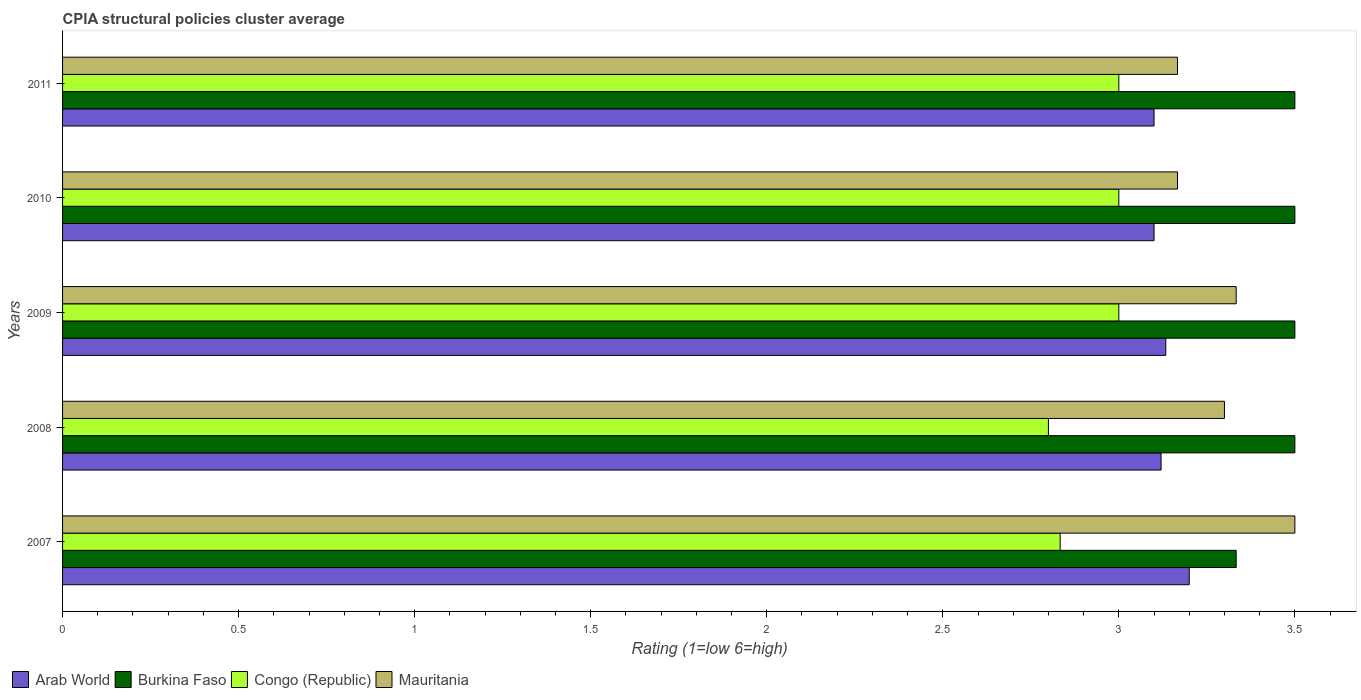How many groups of bars are there?
Your response must be concise. 5. Are the number of bars on each tick of the Y-axis equal?
Provide a succinct answer. Yes. How many bars are there on the 4th tick from the top?
Provide a succinct answer. 4. What is the label of the 5th group of bars from the top?
Ensure brevity in your answer.  2007. What is the CPIA rating in Congo (Republic) in 2009?
Your response must be concise. 3. Across all years, what is the minimum CPIA rating in Arab World?
Ensure brevity in your answer.  3.1. What is the total CPIA rating in Mauritania in the graph?
Give a very brief answer. 16.47. What is the difference between the CPIA rating in Mauritania in 2009 and the CPIA rating in Congo (Republic) in 2008?
Give a very brief answer. 0.53. What is the average CPIA rating in Congo (Republic) per year?
Provide a succinct answer. 2.93. In the year 2010, what is the difference between the CPIA rating in Congo (Republic) and CPIA rating in Arab World?
Provide a short and direct response. -0.1. In how many years, is the CPIA rating in Arab World greater than 2.4 ?
Keep it short and to the point. 5. What is the ratio of the CPIA rating in Burkina Faso in 2008 to that in 2009?
Offer a terse response. 1. What is the difference between the highest and the second highest CPIA rating in Burkina Faso?
Your answer should be very brief. 0. What is the difference between the highest and the lowest CPIA rating in Burkina Faso?
Provide a succinct answer. 0.17. Is it the case that in every year, the sum of the CPIA rating in Congo (Republic) and CPIA rating in Arab World is greater than the sum of CPIA rating in Mauritania and CPIA rating in Burkina Faso?
Your response must be concise. No. What does the 2nd bar from the top in 2008 represents?
Provide a succinct answer. Congo (Republic). What does the 4th bar from the bottom in 2010 represents?
Your answer should be very brief. Mauritania. How many bars are there?
Your response must be concise. 20. Are all the bars in the graph horizontal?
Offer a very short reply. Yes. What is the difference between two consecutive major ticks on the X-axis?
Your response must be concise. 0.5. Does the graph contain any zero values?
Your answer should be very brief. No. How are the legend labels stacked?
Your answer should be very brief. Horizontal. What is the title of the graph?
Make the answer very short. CPIA structural policies cluster average. Does "Sint Maarten (Dutch part)" appear as one of the legend labels in the graph?
Give a very brief answer. No. What is the label or title of the X-axis?
Offer a very short reply. Rating (1=low 6=high). What is the label or title of the Y-axis?
Provide a succinct answer. Years. What is the Rating (1=low 6=high) of Arab World in 2007?
Ensure brevity in your answer.  3.2. What is the Rating (1=low 6=high) of Burkina Faso in 2007?
Your answer should be very brief. 3.33. What is the Rating (1=low 6=high) of Congo (Republic) in 2007?
Keep it short and to the point. 2.83. What is the Rating (1=low 6=high) of Mauritania in 2007?
Provide a short and direct response. 3.5. What is the Rating (1=low 6=high) in Arab World in 2008?
Your response must be concise. 3.12. What is the Rating (1=low 6=high) of Mauritania in 2008?
Provide a succinct answer. 3.3. What is the Rating (1=low 6=high) in Arab World in 2009?
Give a very brief answer. 3.13. What is the Rating (1=low 6=high) of Burkina Faso in 2009?
Keep it short and to the point. 3.5. What is the Rating (1=low 6=high) of Congo (Republic) in 2009?
Offer a very short reply. 3. What is the Rating (1=low 6=high) of Mauritania in 2009?
Provide a succinct answer. 3.33. What is the Rating (1=low 6=high) of Arab World in 2010?
Provide a short and direct response. 3.1. What is the Rating (1=low 6=high) in Burkina Faso in 2010?
Provide a succinct answer. 3.5. What is the Rating (1=low 6=high) in Congo (Republic) in 2010?
Offer a very short reply. 3. What is the Rating (1=low 6=high) in Mauritania in 2010?
Offer a terse response. 3.17. What is the Rating (1=low 6=high) of Arab World in 2011?
Your answer should be compact. 3.1. What is the Rating (1=low 6=high) in Burkina Faso in 2011?
Offer a very short reply. 3.5. What is the Rating (1=low 6=high) of Mauritania in 2011?
Keep it short and to the point. 3.17. Across all years, what is the maximum Rating (1=low 6=high) of Burkina Faso?
Your answer should be compact. 3.5. Across all years, what is the maximum Rating (1=low 6=high) in Congo (Republic)?
Provide a succinct answer. 3. Across all years, what is the maximum Rating (1=low 6=high) in Mauritania?
Ensure brevity in your answer.  3.5. Across all years, what is the minimum Rating (1=low 6=high) in Arab World?
Your answer should be very brief. 3.1. Across all years, what is the minimum Rating (1=low 6=high) in Burkina Faso?
Give a very brief answer. 3.33. Across all years, what is the minimum Rating (1=low 6=high) in Mauritania?
Ensure brevity in your answer.  3.17. What is the total Rating (1=low 6=high) in Arab World in the graph?
Make the answer very short. 15.65. What is the total Rating (1=low 6=high) of Burkina Faso in the graph?
Give a very brief answer. 17.33. What is the total Rating (1=low 6=high) of Congo (Republic) in the graph?
Keep it short and to the point. 14.63. What is the total Rating (1=low 6=high) in Mauritania in the graph?
Offer a very short reply. 16.47. What is the difference between the Rating (1=low 6=high) of Congo (Republic) in 2007 and that in 2008?
Ensure brevity in your answer.  0.03. What is the difference between the Rating (1=low 6=high) in Mauritania in 2007 and that in 2008?
Provide a short and direct response. 0.2. What is the difference between the Rating (1=low 6=high) of Arab World in 2007 and that in 2009?
Your response must be concise. 0.07. What is the difference between the Rating (1=low 6=high) of Congo (Republic) in 2007 and that in 2009?
Your answer should be very brief. -0.17. What is the difference between the Rating (1=low 6=high) of Mauritania in 2007 and that in 2009?
Keep it short and to the point. 0.17. What is the difference between the Rating (1=low 6=high) of Arab World in 2007 and that in 2010?
Offer a terse response. 0.1. What is the difference between the Rating (1=low 6=high) in Congo (Republic) in 2007 and that in 2010?
Ensure brevity in your answer.  -0.17. What is the difference between the Rating (1=low 6=high) of Mauritania in 2007 and that in 2010?
Your answer should be compact. 0.33. What is the difference between the Rating (1=low 6=high) in Burkina Faso in 2007 and that in 2011?
Your response must be concise. -0.17. What is the difference between the Rating (1=low 6=high) of Arab World in 2008 and that in 2009?
Your answer should be very brief. -0.01. What is the difference between the Rating (1=low 6=high) of Burkina Faso in 2008 and that in 2009?
Your response must be concise. 0. What is the difference between the Rating (1=low 6=high) in Mauritania in 2008 and that in 2009?
Provide a short and direct response. -0.03. What is the difference between the Rating (1=low 6=high) in Burkina Faso in 2008 and that in 2010?
Provide a short and direct response. 0. What is the difference between the Rating (1=low 6=high) in Mauritania in 2008 and that in 2010?
Keep it short and to the point. 0.13. What is the difference between the Rating (1=low 6=high) in Congo (Republic) in 2008 and that in 2011?
Offer a terse response. -0.2. What is the difference between the Rating (1=low 6=high) in Mauritania in 2008 and that in 2011?
Ensure brevity in your answer.  0.13. What is the difference between the Rating (1=low 6=high) in Arab World in 2009 and that in 2010?
Keep it short and to the point. 0.03. What is the difference between the Rating (1=low 6=high) of Mauritania in 2009 and that in 2010?
Offer a terse response. 0.17. What is the difference between the Rating (1=low 6=high) in Burkina Faso in 2009 and that in 2011?
Offer a very short reply. 0. What is the difference between the Rating (1=low 6=high) of Mauritania in 2009 and that in 2011?
Give a very brief answer. 0.17. What is the difference between the Rating (1=low 6=high) in Arab World in 2007 and the Rating (1=low 6=high) in Burkina Faso in 2008?
Provide a succinct answer. -0.3. What is the difference between the Rating (1=low 6=high) in Arab World in 2007 and the Rating (1=low 6=high) in Congo (Republic) in 2008?
Provide a short and direct response. 0.4. What is the difference between the Rating (1=low 6=high) in Burkina Faso in 2007 and the Rating (1=low 6=high) in Congo (Republic) in 2008?
Provide a short and direct response. 0.53. What is the difference between the Rating (1=low 6=high) in Congo (Republic) in 2007 and the Rating (1=low 6=high) in Mauritania in 2008?
Provide a succinct answer. -0.47. What is the difference between the Rating (1=low 6=high) in Arab World in 2007 and the Rating (1=low 6=high) in Burkina Faso in 2009?
Your answer should be very brief. -0.3. What is the difference between the Rating (1=low 6=high) of Arab World in 2007 and the Rating (1=low 6=high) of Mauritania in 2009?
Your answer should be compact. -0.13. What is the difference between the Rating (1=low 6=high) of Arab World in 2007 and the Rating (1=low 6=high) of Congo (Republic) in 2010?
Offer a very short reply. 0.2. What is the difference between the Rating (1=low 6=high) in Arab World in 2007 and the Rating (1=low 6=high) in Mauritania in 2010?
Provide a succinct answer. 0.03. What is the difference between the Rating (1=low 6=high) in Burkina Faso in 2007 and the Rating (1=low 6=high) in Mauritania in 2010?
Make the answer very short. 0.17. What is the difference between the Rating (1=low 6=high) in Arab World in 2007 and the Rating (1=low 6=high) in Congo (Republic) in 2011?
Make the answer very short. 0.2. What is the difference between the Rating (1=low 6=high) of Burkina Faso in 2007 and the Rating (1=low 6=high) of Congo (Republic) in 2011?
Offer a terse response. 0.33. What is the difference between the Rating (1=low 6=high) in Congo (Republic) in 2007 and the Rating (1=low 6=high) in Mauritania in 2011?
Ensure brevity in your answer.  -0.33. What is the difference between the Rating (1=low 6=high) of Arab World in 2008 and the Rating (1=low 6=high) of Burkina Faso in 2009?
Make the answer very short. -0.38. What is the difference between the Rating (1=low 6=high) in Arab World in 2008 and the Rating (1=low 6=high) in Congo (Republic) in 2009?
Ensure brevity in your answer.  0.12. What is the difference between the Rating (1=low 6=high) in Arab World in 2008 and the Rating (1=low 6=high) in Mauritania in 2009?
Make the answer very short. -0.21. What is the difference between the Rating (1=low 6=high) of Congo (Republic) in 2008 and the Rating (1=low 6=high) of Mauritania in 2009?
Provide a succinct answer. -0.53. What is the difference between the Rating (1=low 6=high) of Arab World in 2008 and the Rating (1=low 6=high) of Burkina Faso in 2010?
Offer a terse response. -0.38. What is the difference between the Rating (1=low 6=high) of Arab World in 2008 and the Rating (1=low 6=high) of Congo (Republic) in 2010?
Provide a succinct answer. 0.12. What is the difference between the Rating (1=low 6=high) of Arab World in 2008 and the Rating (1=low 6=high) of Mauritania in 2010?
Provide a succinct answer. -0.05. What is the difference between the Rating (1=low 6=high) in Burkina Faso in 2008 and the Rating (1=low 6=high) in Mauritania in 2010?
Your answer should be very brief. 0.33. What is the difference between the Rating (1=low 6=high) of Congo (Republic) in 2008 and the Rating (1=low 6=high) of Mauritania in 2010?
Keep it short and to the point. -0.37. What is the difference between the Rating (1=low 6=high) in Arab World in 2008 and the Rating (1=low 6=high) in Burkina Faso in 2011?
Make the answer very short. -0.38. What is the difference between the Rating (1=low 6=high) of Arab World in 2008 and the Rating (1=low 6=high) of Congo (Republic) in 2011?
Your answer should be very brief. 0.12. What is the difference between the Rating (1=low 6=high) in Arab World in 2008 and the Rating (1=low 6=high) in Mauritania in 2011?
Make the answer very short. -0.05. What is the difference between the Rating (1=low 6=high) in Burkina Faso in 2008 and the Rating (1=low 6=high) in Congo (Republic) in 2011?
Offer a terse response. 0.5. What is the difference between the Rating (1=low 6=high) in Burkina Faso in 2008 and the Rating (1=low 6=high) in Mauritania in 2011?
Keep it short and to the point. 0.33. What is the difference between the Rating (1=low 6=high) of Congo (Republic) in 2008 and the Rating (1=low 6=high) of Mauritania in 2011?
Offer a very short reply. -0.37. What is the difference between the Rating (1=low 6=high) of Arab World in 2009 and the Rating (1=low 6=high) of Burkina Faso in 2010?
Provide a succinct answer. -0.37. What is the difference between the Rating (1=low 6=high) of Arab World in 2009 and the Rating (1=low 6=high) of Congo (Republic) in 2010?
Make the answer very short. 0.13. What is the difference between the Rating (1=low 6=high) in Arab World in 2009 and the Rating (1=low 6=high) in Mauritania in 2010?
Your answer should be compact. -0.03. What is the difference between the Rating (1=low 6=high) of Burkina Faso in 2009 and the Rating (1=low 6=high) of Mauritania in 2010?
Provide a short and direct response. 0.33. What is the difference between the Rating (1=low 6=high) in Congo (Republic) in 2009 and the Rating (1=low 6=high) in Mauritania in 2010?
Your answer should be compact. -0.17. What is the difference between the Rating (1=low 6=high) of Arab World in 2009 and the Rating (1=low 6=high) of Burkina Faso in 2011?
Your answer should be very brief. -0.37. What is the difference between the Rating (1=low 6=high) in Arab World in 2009 and the Rating (1=low 6=high) in Congo (Republic) in 2011?
Ensure brevity in your answer.  0.13. What is the difference between the Rating (1=low 6=high) of Arab World in 2009 and the Rating (1=low 6=high) of Mauritania in 2011?
Your answer should be very brief. -0.03. What is the difference between the Rating (1=low 6=high) in Burkina Faso in 2009 and the Rating (1=low 6=high) in Congo (Republic) in 2011?
Your response must be concise. 0.5. What is the difference between the Rating (1=low 6=high) of Burkina Faso in 2009 and the Rating (1=low 6=high) of Mauritania in 2011?
Offer a very short reply. 0.33. What is the difference between the Rating (1=low 6=high) of Arab World in 2010 and the Rating (1=low 6=high) of Burkina Faso in 2011?
Your answer should be compact. -0.4. What is the difference between the Rating (1=low 6=high) of Arab World in 2010 and the Rating (1=low 6=high) of Mauritania in 2011?
Give a very brief answer. -0.07. What is the difference between the Rating (1=low 6=high) of Congo (Republic) in 2010 and the Rating (1=low 6=high) of Mauritania in 2011?
Keep it short and to the point. -0.17. What is the average Rating (1=low 6=high) of Arab World per year?
Offer a terse response. 3.13. What is the average Rating (1=low 6=high) of Burkina Faso per year?
Your answer should be compact. 3.47. What is the average Rating (1=low 6=high) in Congo (Republic) per year?
Make the answer very short. 2.93. What is the average Rating (1=low 6=high) in Mauritania per year?
Make the answer very short. 3.29. In the year 2007, what is the difference between the Rating (1=low 6=high) in Arab World and Rating (1=low 6=high) in Burkina Faso?
Give a very brief answer. -0.13. In the year 2007, what is the difference between the Rating (1=low 6=high) in Arab World and Rating (1=low 6=high) in Congo (Republic)?
Your response must be concise. 0.37. In the year 2007, what is the difference between the Rating (1=low 6=high) in Arab World and Rating (1=low 6=high) in Mauritania?
Give a very brief answer. -0.3. In the year 2007, what is the difference between the Rating (1=low 6=high) in Burkina Faso and Rating (1=low 6=high) in Congo (Republic)?
Offer a terse response. 0.5. In the year 2008, what is the difference between the Rating (1=low 6=high) in Arab World and Rating (1=low 6=high) in Burkina Faso?
Your answer should be compact. -0.38. In the year 2008, what is the difference between the Rating (1=low 6=high) of Arab World and Rating (1=low 6=high) of Congo (Republic)?
Your answer should be compact. 0.32. In the year 2008, what is the difference between the Rating (1=low 6=high) in Arab World and Rating (1=low 6=high) in Mauritania?
Offer a terse response. -0.18. In the year 2008, what is the difference between the Rating (1=low 6=high) of Burkina Faso and Rating (1=low 6=high) of Congo (Republic)?
Give a very brief answer. 0.7. In the year 2008, what is the difference between the Rating (1=low 6=high) of Burkina Faso and Rating (1=low 6=high) of Mauritania?
Ensure brevity in your answer.  0.2. In the year 2009, what is the difference between the Rating (1=low 6=high) in Arab World and Rating (1=low 6=high) in Burkina Faso?
Provide a short and direct response. -0.37. In the year 2009, what is the difference between the Rating (1=low 6=high) of Arab World and Rating (1=low 6=high) of Congo (Republic)?
Provide a short and direct response. 0.13. In the year 2010, what is the difference between the Rating (1=low 6=high) in Arab World and Rating (1=low 6=high) in Mauritania?
Make the answer very short. -0.07. In the year 2010, what is the difference between the Rating (1=low 6=high) of Burkina Faso and Rating (1=low 6=high) of Congo (Republic)?
Give a very brief answer. 0.5. In the year 2011, what is the difference between the Rating (1=low 6=high) of Arab World and Rating (1=low 6=high) of Congo (Republic)?
Your response must be concise. 0.1. In the year 2011, what is the difference between the Rating (1=low 6=high) in Arab World and Rating (1=low 6=high) in Mauritania?
Your answer should be compact. -0.07. In the year 2011, what is the difference between the Rating (1=low 6=high) of Burkina Faso and Rating (1=low 6=high) of Mauritania?
Offer a very short reply. 0.33. What is the ratio of the Rating (1=low 6=high) in Arab World in 2007 to that in 2008?
Keep it short and to the point. 1.03. What is the ratio of the Rating (1=low 6=high) in Congo (Republic) in 2007 to that in 2008?
Provide a succinct answer. 1.01. What is the ratio of the Rating (1=low 6=high) of Mauritania in 2007 to that in 2008?
Provide a short and direct response. 1.06. What is the ratio of the Rating (1=low 6=high) in Arab World in 2007 to that in 2009?
Provide a succinct answer. 1.02. What is the ratio of the Rating (1=low 6=high) of Burkina Faso in 2007 to that in 2009?
Make the answer very short. 0.95. What is the ratio of the Rating (1=low 6=high) of Arab World in 2007 to that in 2010?
Your response must be concise. 1.03. What is the ratio of the Rating (1=low 6=high) of Congo (Republic) in 2007 to that in 2010?
Your answer should be compact. 0.94. What is the ratio of the Rating (1=low 6=high) in Mauritania in 2007 to that in 2010?
Give a very brief answer. 1.11. What is the ratio of the Rating (1=low 6=high) in Arab World in 2007 to that in 2011?
Offer a very short reply. 1.03. What is the ratio of the Rating (1=low 6=high) in Burkina Faso in 2007 to that in 2011?
Make the answer very short. 0.95. What is the ratio of the Rating (1=low 6=high) of Congo (Republic) in 2007 to that in 2011?
Your answer should be very brief. 0.94. What is the ratio of the Rating (1=low 6=high) in Mauritania in 2007 to that in 2011?
Provide a succinct answer. 1.11. What is the ratio of the Rating (1=low 6=high) of Arab World in 2008 to that in 2009?
Ensure brevity in your answer.  1. What is the ratio of the Rating (1=low 6=high) in Congo (Republic) in 2008 to that in 2009?
Your response must be concise. 0.93. What is the ratio of the Rating (1=low 6=high) of Burkina Faso in 2008 to that in 2010?
Offer a terse response. 1. What is the ratio of the Rating (1=low 6=high) of Mauritania in 2008 to that in 2010?
Your answer should be very brief. 1.04. What is the ratio of the Rating (1=low 6=high) of Arab World in 2008 to that in 2011?
Offer a terse response. 1.01. What is the ratio of the Rating (1=low 6=high) of Mauritania in 2008 to that in 2011?
Keep it short and to the point. 1.04. What is the ratio of the Rating (1=low 6=high) of Arab World in 2009 to that in 2010?
Provide a succinct answer. 1.01. What is the ratio of the Rating (1=low 6=high) in Mauritania in 2009 to that in 2010?
Your answer should be very brief. 1.05. What is the ratio of the Rating (1=low 6=high) of Arab World in 2009 to that in 2011?
Offer a very short reply. 1.01. What is the ratio of the Rating (1=low 6=high) in Burkina Faso in 2009 to that in 2011?
Make the answer very short. 1. What is the ratio of the Rating (1=low 6=high) of Mauritania in 2009 to that in 2011?
Ensure brevity in your answer.  1.05. What is the ratio of the Rating (1=low 6=high) of Burkina Faso in 2010 to that in 2011?
Your answer should be compact. 1. What is the ratio of the Rating (1=low 6=high) of Mauritania in 2010 to that in 2011?
Provide a succinct answer. 1. What is the difference between the highest and the second highest Rating (1=low 6=high) in Arab World?
Your answer should be very brief. 0.07. What is the difference between the highest and the second highest Rating (1=low 6=high) in Burkina Faso?
Your response must be concise. 0. What is the difference between the highest and the second highest Rating (1=low 6=high) in Congo (Republic)?
Offer a very short reply. 0. What is the difference between the highest and the second highest Rating (1=low 6=high) in Mauritania?
Provide a short and direct response. 0.17. What is the difference between the highest and the lowest Rating (1=low 6=high) of Burkina Faso?
Give a very brief answer. 0.17. What is the difference between the highest and the lowest Rating (1=low 6=high) in Congo (Republic)?
Make the answer very short. 0.2. 